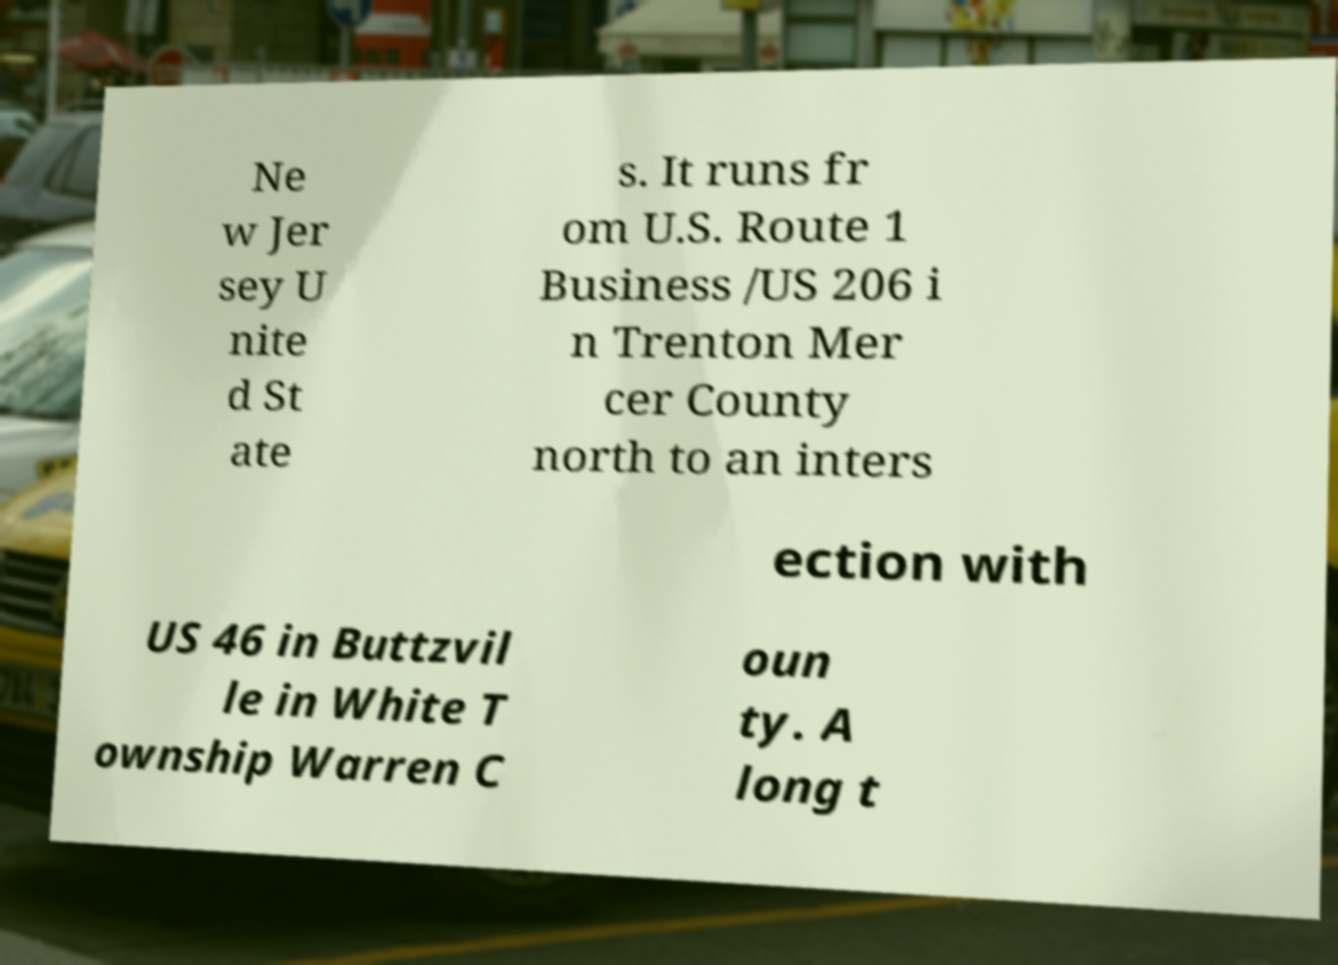Please identify and transcribe the text found in this image. Ne w Jer sey U nite d St ate s. It runs fr om U.S. Route 1 Business /US 206 i n Trenton Mer cer County north to an inters ection with US 46 in Buttzvil le in White T ownship Warren C oun ty. A long t 